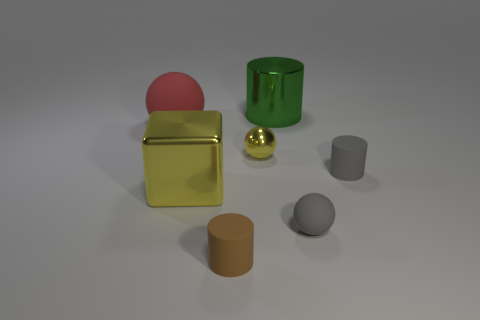There is a rubber ball that is to the left of the large green cylinder; how big is it?
Provide a short and direct response. Large. What size is the sphere that is the same color as the large block?
Provide a succinct answer. Small. Are there any gray balls that have the same material as the tiny brown object?
Ensure brevity in your answer.  Yes. Is the material of the brown object the same as the large ball?
Your response must be concise. Yes. There is another ball that is the same size as the shiny sphere; what is its color?
Your answer should be very brief. Gray. How many other things are there of the same shape as the tiny shiny object?
Offer a very short reply. 2. Do the shiny block and the gray rubber cylinder that is behind the large yellow cube have the same size?
Your answer should be compact. No. How many objects are either large purple matte cylinders or brown matte cylinders?
Ensure brevity in your answer.  1. How many other objects are there of the same size as the yellow sphere?
Offer a very short reply. 3. Is the color of the small metal ball the same as the rubber object in front of the small gray ball?
Provide a short and direct response. No. 